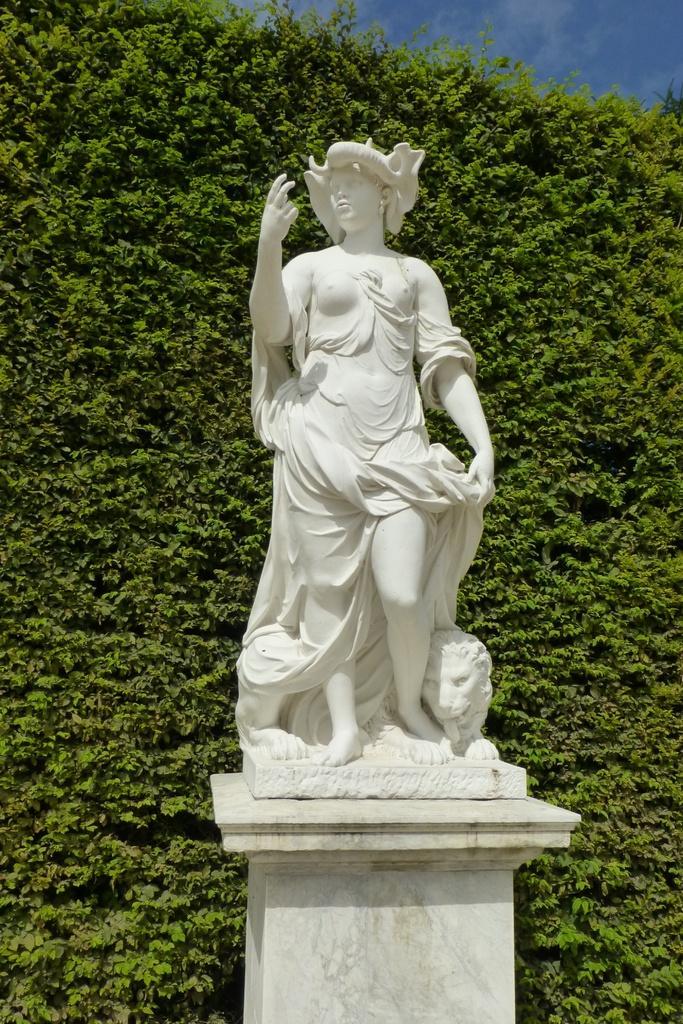How would you summarize this image in a sentence or two? In this image there is a sculpture on a pillar. There is a woman standing. Beside the woman there is an animal. Behind the sculpture there are hedges. At the top there is the sky. 